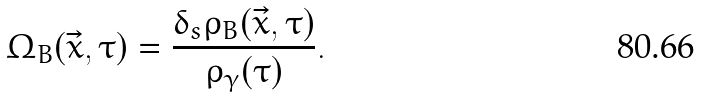Convert formula to latex. <formula><loc_0><loc_0><loc_500><loc_500>\Omega _ { B } ( \vec { x } , \tau ) = \frac { \delta _ { s } \rho _ { B } ( \vec { x } , \tau ) } { \rho _ { \gamma } ( \tau ) } .</formula> 